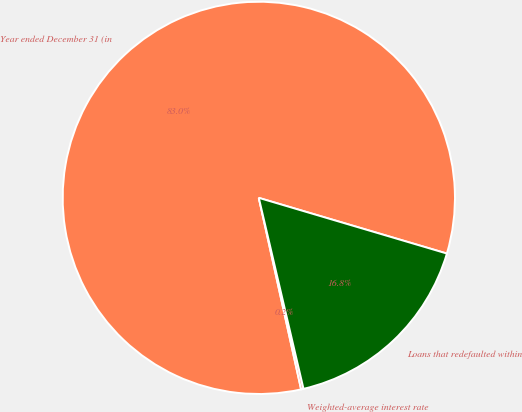Convert chart. <chart><loc_0><loc_0><loc_500><loc_500><pie_chart><fcel>Year ended December 31 (in<fcel>Weighted-average interest rate<fcel>Loans that redefaulted within<nl><fcel>83.04%<fcel>0.2%<fcel>16.76%<nl></chart> 